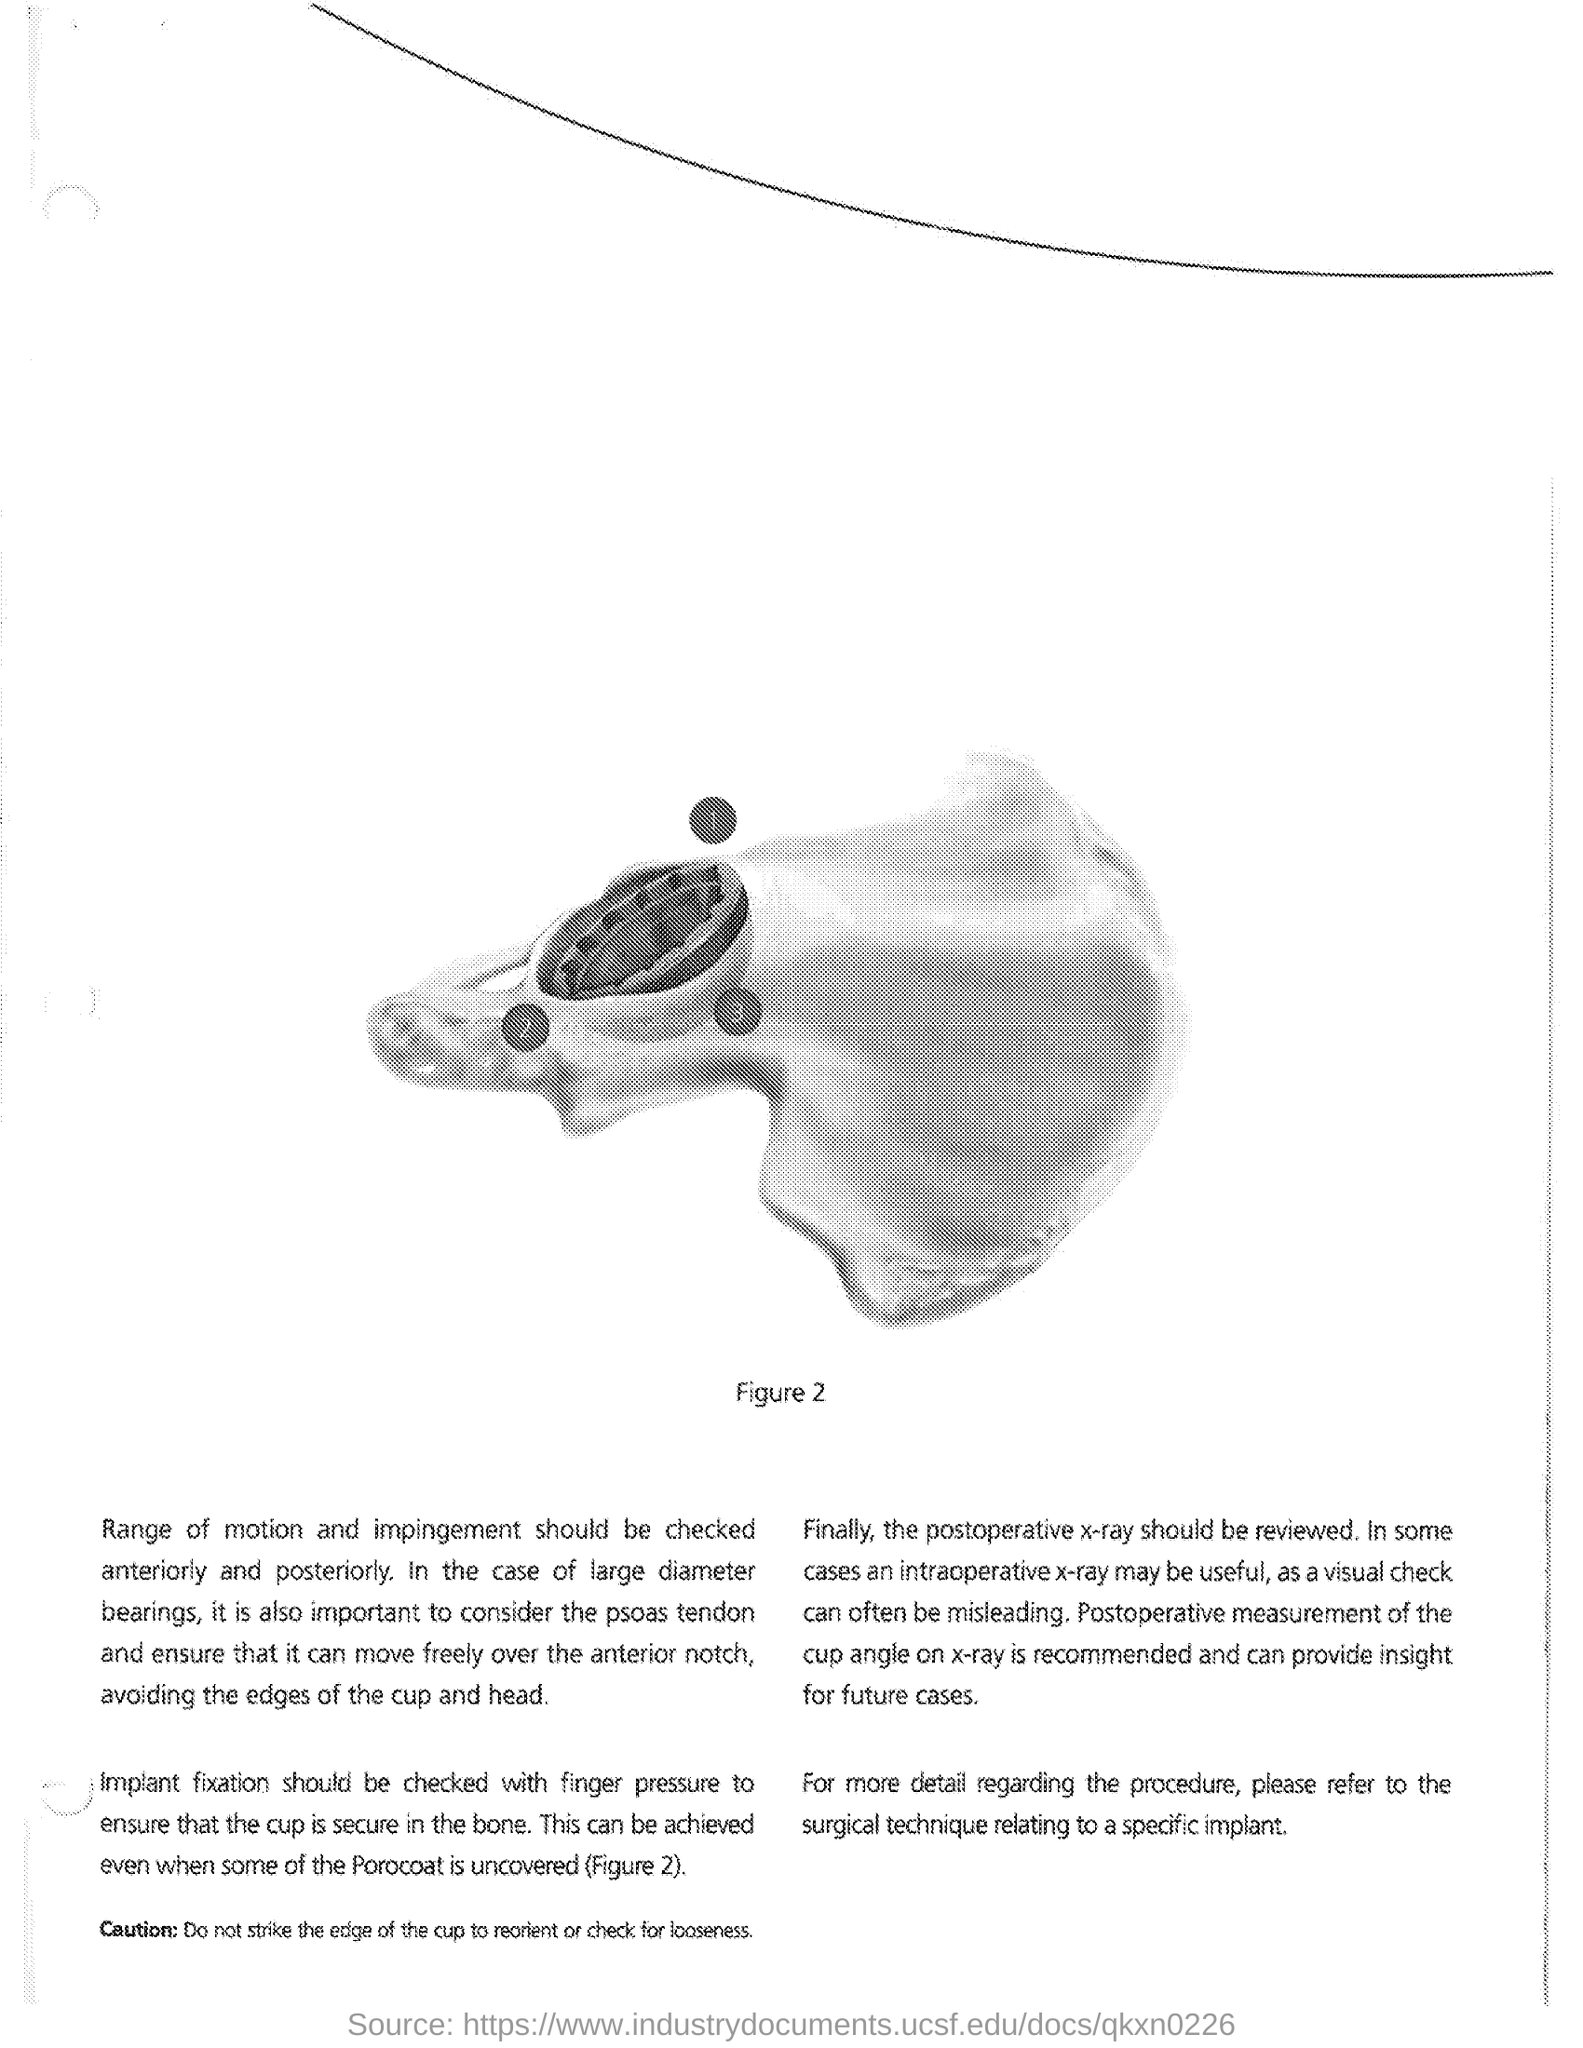Indicate a few pertinent items in this graphic. For more detailed information regarding surgical techniques specifically related to a particular implant, please refer to... Postoperative measurement of the cup angle on x-ray can provide valuable insight for further cases. The figure number is 2. It is important to thoroughly check the implant fixation to ensure that the cup is securely fixed in the bone. This can be achieved by applying finger pressure to the implant and cup to confirm that they are stable and well-positioned. 